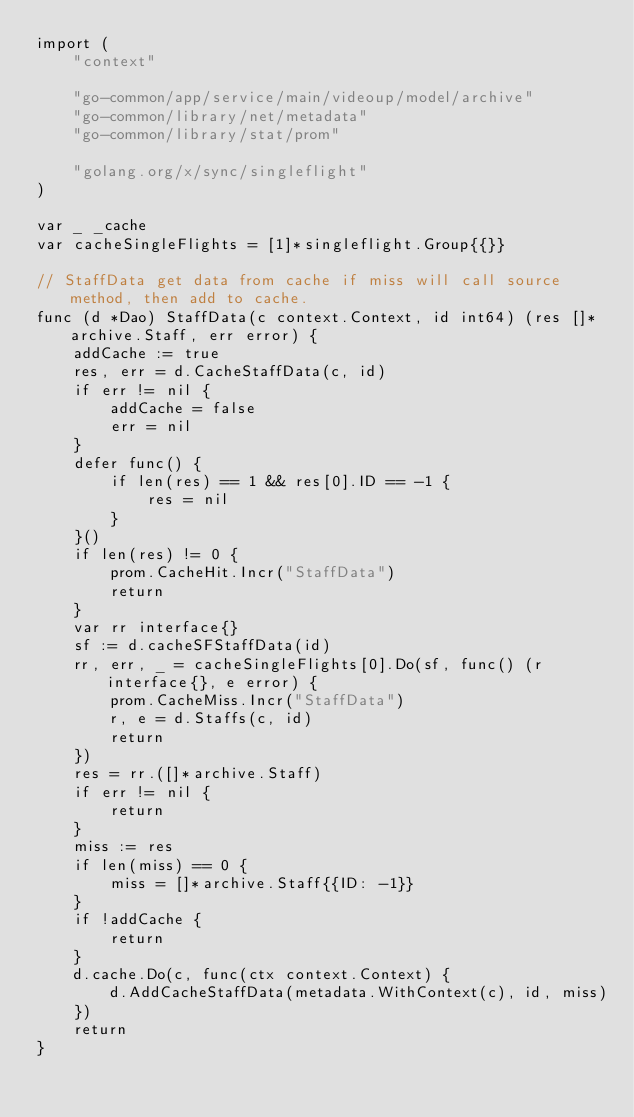Convert code to text. <code><loc_0><loc_0><loc_500><loc_500><_Go_>import (
	"context"

	"go-common/app/service/main/videoup/model/archive"
	"go-common/library/net/metadata"
	"go-common/library/stat/prom"

	"golang.org/x/sync/singleflight"
)

var _ _cache
var cacheSingleFlights = [1]*singleflight.Group{{}}

// StaffData get data from cache if miss will call source method, then add to cache.
func (d *Dao) StaffData(c context.Context, id int64) (res []*archive.Staff, err error) {
	addCache := true
	res, err = d.CacheStaffData(c, id)
	if err != nil {
		addCache = false
		err = nil
	}
	defer func() {
		if len(res) == 1 && res[0].ID == -1 {
			res = nil
		}
	}()
	if len(res) != 0 {
		prom.CacheHit.Incr("StaffData")
		return
	}
	var rr interface{}
	sf := d.cacheSFStaffData(id)
	rr, err, _ = cacheSingleFlights[0].Do(sf, func() (r interface{}, e error) {
		prom.CacheMiss.Incr("StaffData")
		r, e = d.Staffs(c, id)
		return
	})
	res = rr.([]*archive.Staff)
	if err != nil {
		return
	}
	miss := res
	if len(miss) == 0 {
		miss = []*archive.Staff{{ID: -1}}
	}
	if !addCache {
		return
	}
	d.cache.Do(c, func(ctx context.Context) {
		d.AddCacheStaffData(metadata.WithContext(c), id, miss)
	})
	return
}
</code> 